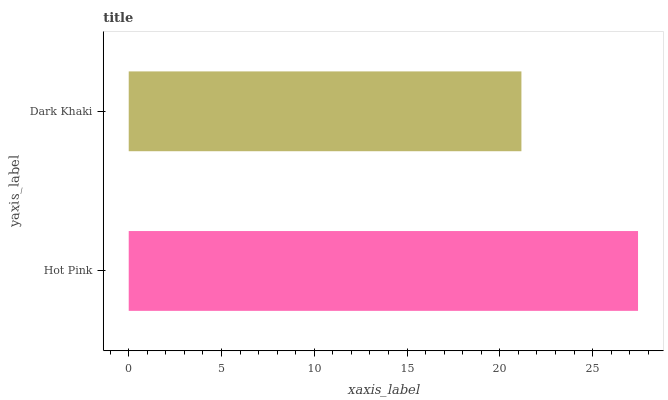Is Dark Khaki the minimum?
Answer yes or no. Yes. Is Hot Pink the maximum?
Answer yes or no. Yes. Is Dark Khaki the maximum?
Answer yes or no. No. Is Hot Pink greater than Dark Khaki?
Answer yes or no. Yes. Is Dark Khaki less than Hot Pink?
Answer yes or no. Yes. Is Dark Khaki greater than Hot Pink?
Answer yes or no. No. Is Hot Pink less than Dark Khaki?
Answer yes or no. No. Is Hot Pink the high median?
Answer yes or no. Yes. Is Dark Khaki the low median?
Answer yes or no. Yes. Is Dark Khaki the high median?
Answer yes or no. No. Is Hot Pink the low median?
Answer yes or no. No. 